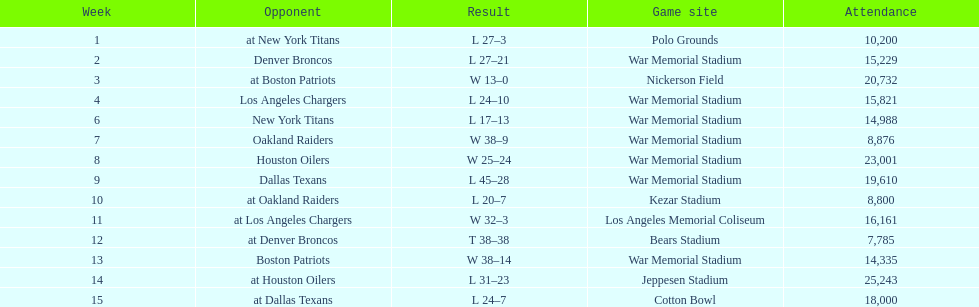Who was the opponent during for first week? New York Titans. 